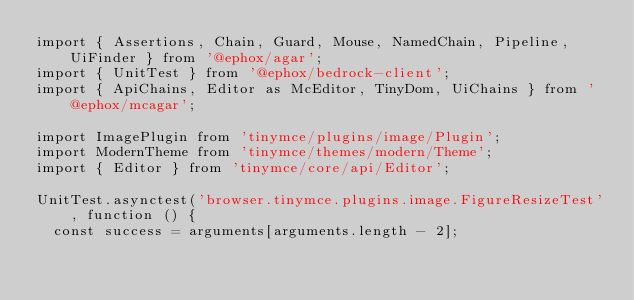Convert code to text. <code><loc_0><loc_0><loc_500><loc_500><_TypeScript_>import { Assertions, Chain, Guard, Mouse, NamedChain, Pipeline, UiFinder } from '@ephox/agar';
import { UnitTest } from '@ephox/bedrock-client';
import { ApiChains, Editor as McEditor, TinyDom, UiChains } from '@ephox/mcagar';

import ImagePlugin from 'tinymce/plugins/image/Plugin';
import ModernTheme from 'tinymce/themes/modern/Theme';
import { Editor } from 'tinymce/core/api/Editor';

UnitTest.asynctest('browser.tinymce.plugins.image.FigureResizeTest', function () {
  const success = arguments[arguments.length - 2];</code> 